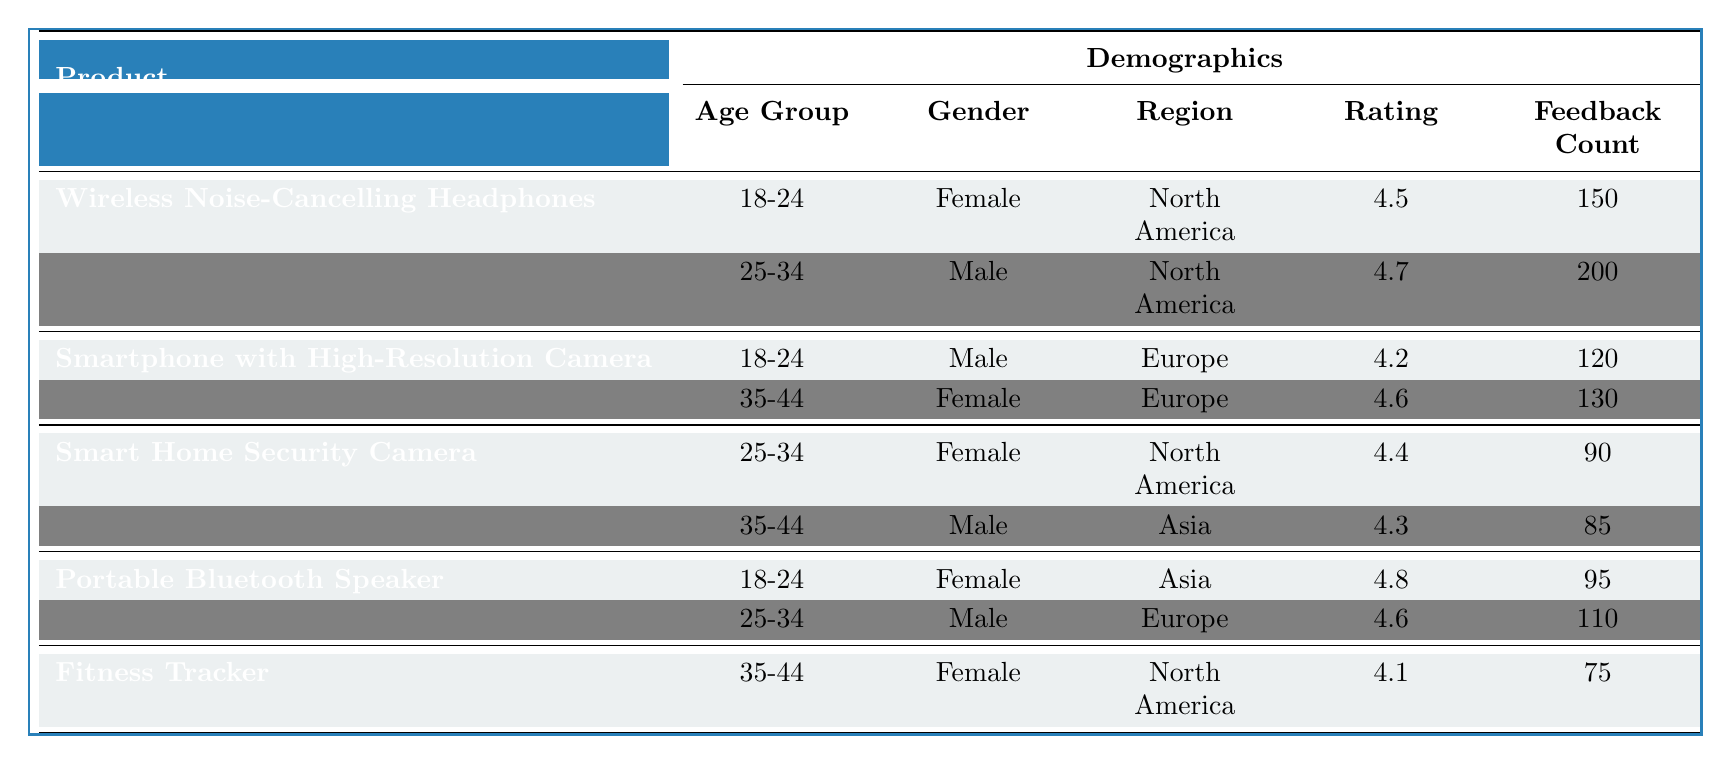What is the rating for the "Wireless Noise-Cancelling Headphones" in the 25-34 age group? The table indicates that for the product "Wireless Noise-Cancelling Headphones," the rating for the demographic of 25-34 age group is listed as 4.7.
Answer: 4.7 Which product has the highest feedback count? By reviewing the feedback count for each product, "Wireless Noise-Cancelling Headphones" has a feedback count of 200, which is higher than any other product's feedback count.
Answer: Wireless Noise-Cancelling Headphones Is the rating for the "Smartphone with High-Resolution Camera" higher among females compared to males? The table shows a rating of 4.6 for females (35-44 age group) and a rating of 4.2 for males (18-24 age group) for the product "Smartphone with High-Resolution Camera," indicating that the female rating is higher.
Answer: Yes What is the average rating for the products across all demographics? The ratings are 4.5, 4.7, 4.2, 4.6, 4.4, 4.3, 4.8, 4.6, and 4.1. Summing these gives 4.5 + 4.7 + 4.2 + 4.6 + 4.4 + 4.3 + 4.8 + 4.6 + 4.1 = 40.2. There are 9 ratings, so the average is 40.2 / 9 = 4.47.
Answer: 4.47 For the "Portable Bluetooth Speaker," do both demographics have a rating above 4.5? The ratings for the "Portable Bluetooth Speaker" are 4.8 (18-24, Female) and 4.6 (25-34, Male), both of which are above 4.5.
Answer: Yes Which region has the highest feedback rating for "Smart Home Security Camera"? The table shows that "Smart Home Security Camera" has a rating of 4.4 for the North America demographic and 4.3 for the Asia demographic. Thus, North America has the higher rating.
Answer: North America What is the total feedback count for the "Fitness Tracker" and "Smart Home Security Camera"? The feedback count for "Fitness Tracker" is 75, and for "Smart Home Security Camera," it is 90. Adding these counts gives 75 + 90 = 165.
Answer: 165 Which age group and gender combination has the lowest rating? Reviewing the ratings in the table, the "Fitness Tracker" for the age group 35-44 and female has the lowest rating of 4.1, which is the lowest overall rating listed in the data.
Answer: 35-44, Female Is there a feedback count entry for any product that is lower than 80? Upon checking the feedback counts, the lowest is 75 for the "Fitness Tracker," indicating that there is indeed an entry below 80.
Answer: Yes 